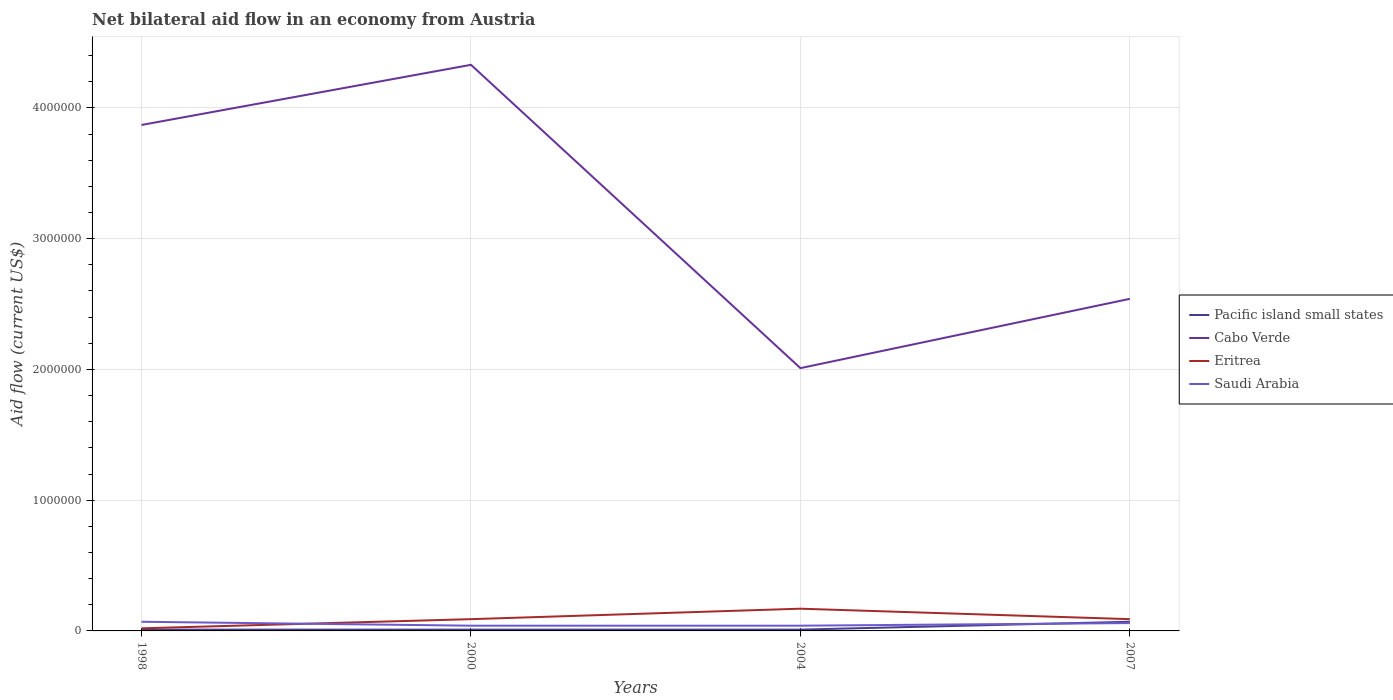Across all years, what is the maximum net bilateral aid flow in Eritrea?
Your answer should be compact. 2.00e+04. In which year was the net bilateral aid flow in Pacific island small states maximum?
Ensure brevity in your answer.  1998. What is the total net bilateral aid flow in Cabo Verde in the graph?
Your answer should be very brief. 2.32e+06. What is the difference between the highest and the lowest net bilateral aid flow in Eritrea?
Provide a succinct answer. 1. How many lines are there?
Make the answer very short. 4. How many years are there in the graph?
Your response must be concise. 4. What is the difference between two consecutive major ticks on the Y-axis?
Make the answer very short. 1.00e+06. Are the values on the major ticks of Y-axis written in scientific E-notation?
Ensure brevity in your answer.  No. Does the graph contain any zero values?
Make the answer very short. No. How are the legend labels stacked?
Offer a terse response. Vertical. What is the title of the graph?
Provide a succinct answer. Net bilateral aid flow in an economy from Austria. Does "Burundi" appear as one of the legend labels in the graph?
Make the answer very short. No. What is the label or title of the Y-axis?
Offer a terse response. Aid flow (current US$). What is the Aid flow (current US$) of Cabo Verde in 1998?
Provide a succinct answer. 3.87e+06. What is the Aid flow (current US$) in Saudi Arabia in 1998?
Give a very brief answer. 7.00e+04. What is the Aid flow (current US$) in Pacific island small states in 2000?
Provide a succinct answer. 10000. What is the Aid flow (current US$) in Cabo Verde in 2000?
Make the answer very short. 4.33e+06. What is the Aid flow (current US$) of Saudi Arabia in 2000?
Your answer should be very brief. 4.00e+04. What is the Aid flow (current US$) in Pacific island small states in 2004?
Your response must be concise. 10000. What is the Aid flow (current US$) of Cabo Verde in 2004?
Provide a short and direct response. 2.01e+06. What is the Aid flow (current US$) of Saudi Arabia in 2004?
Your answer should be very brief. 4.00e+04. What is the Aid flow (current US$) of Cabo Verde in 2007?
Provide a succinct answer. 2.54e+06. Across all years, what is the maximum Aid flow (current US$) in Pacific island small states?
Give a very brief answer. 7.00e+04. Across all years, what is the maximum Aid flow (current US$) in Cabo Verde?
Your answer should be very brief. 4.33e+06. Across all years, what is the maximum Aid flow (current US$) in Saudi Arabia?
Offer a terse response. 7.00e+04. Across all years, what is the minimum Aid flow (current US$) in Cabo Verde?
Your response must be concise. 2.01e+06. What is the total Aid flow (current US$) of Cabo Verde in the graph?
Provide a short and direct response. 1.28e+07. What is the total Aid flow (current US$) in Eritrea in the graph?
Offer a terse response. 3.70e+05. What is the total Aid flow (current US$) of Saudi Arabia in the graph?
Offer a terse response. 2.10e+05. What is the difference between the Aid flow (current US$) in Cabo Verde in 1998 and that in 2000?
Provide a short and direct response. -4.60e+05. What is the difference between the Aid flow (current US$) in Eritrea in 1998 and that in 2000?
Provide a succinct answer. -7.00e+04. What is the difference between the Aid flow (current US$) of Saudi Arabia in 1998 and that in 2000?
Make the answer very short. 3.00e+04. What is the difference between the Aid flow (current US$) of Cabo Verde in 1998 and that in 2004?
Keep it short and to the point. 1.86e+06. What is the difference between the Aid flow (current US$) in Saudi Arabia in 1998 and that in 2004?
Offer a terse response. 3.00e+04. What is the difference between the Aid flow (current US$) in Pacific island small states in 1998 and that in 2007?
Provide a short and direct response. -6.00e+04. What is the difference between the Aid flow (current US$) in Cabo Verde in 1998 and that in 2007?
Provide a short and direct response. 1.33e+06. What is the difference between the Aid flow (current US$) of Cabo Verde in 2000 and that in 2004?
Provide a succinct answer. 2.32e+06. What is the difference between the Aid flow (current US$) in Eritrea in 2000 and that in 2004?
Offer a terse response. -8.00e+04. What is the difference between the Aid flow (current US$) in Cabo Verde in 2000 and that in 2007?
Provide a succinct answer. 1.79e+06. What is the difference between the Aid flow (current US$) in Cabo Verde in 2004 and that in 2007?
Ensure brevity in your answer.  -5.30e+05. What is the difference between the Aid flow (current US$) of Pacific island small states in 1998 and the Aid flow (current US$) of Cabo Verde in 2000?
Your answer should be very brief. -4.32e+06. What is the difference between the Aid flow (current US$) in Cabo Verde in 1998 and the Aid flow (current US$) in Eritrea in 2000?
Offer a very short reply. 3.78e+06. What is the difference between the Aid flow (current US$) of Cabo Verde in 1998 and the Aid flow (current US$) of Saudi Arabia in 2000?
Keep it short and to the point. 3.83e+06. What is the difference between the Aid flow (current US$) in Pacific island small states in 1998 and the Aid flow (current US$) in Eritrea in 2004?
Keep it short and to the point. -1.60e+05. What is the difference between the Aid flow (current US$) in Cabo Verde in 1998 and the Aid flow (current US$) in Eritrea in 2004?
Your answer should be very brief. 3.70e+06. What is the difference between the Aid flow (current US$) of Cabo Verde in 1998 and the Aid flow (current US$) of Saudi Arabia in 2004?
Give a very brief answer. 3.83e+06. What is the difference between the Aid flow (current US$) of Eritrea in 1998 and the Aid flow (current US$) of Saudi Arabia in 2004?
Keep it short and to the point. -2.00e+04. What is the difference between the Aid flow (current US$) of Pacific island small states in 1998 and the Aid flow (current US$) of Cabo Verde in 2007?
Ensure brevity in your answer.  -2.53e+06. What is the difference between the Aid flow (current US$) of Pacific island small states in 1998 and the Aid flow (current US$) of Saudi Arabia in 2007?
Provide a short and direct response. -5.00e+04. What is the difference between the Aid flow (current US$) in Cabo Verde in 1998 and the Aid flow (current US$) in Eritrea in 2007?
Give a very brief answer. 3.78e+06. What is the difference between the Aid flow (current US$) of Cabo Verde in 1998 and the Aid flow (current US$) of Saudi Arabia in 2007?
Your answer should be compact. 3.81e+06. What is the difference between the Aid flow (current US$) in Pacific island small states in 2000 and the Aid flow (current US$) in Cabo Verde in 2004?
Your response must be concise. -2.00e+06. What is the difference between the Aid flow (current US$) of Pacific island small states in 2000 and the Aid flow (current US$) of Eritrea in 2004?
Provide a succinct answer. -1.60e+05. What is the difference between the Aid flow (current US$) of Cabo Verde in 2000 and the Aid flow (current US$) of Eritrea in 2004?
Provide a short and direct response. 4.16e+06. What is the difference between the Aid flow (current US$) in Cabo Verde in 2000 and the Aid flow (current US$) in Saudi Arabia in 2004?
Offer a very short reply. 4.29e+06. What is the difference between the Aid flow (current US$) in Eritrea in 2000 and the Aid flow (current US$) in Saudi Arabia in 2004?
Make the answer very short. 5.00e+04. What is the difference between the Aid flow (current US$) of Pacific island small states in 2000 and the Aid flow (current US$) of Cabo Verde in 2007?
Your response must be concise. -2.53e+06. What is the difference between the Aid flow (current US$) of Pacific island small states in 2000 and the Aid flow (current US$) of Saudi Arabia in 2007?
Your response must be concise. -5.00e+04. What is the difference between the Aid flow (current US$) of Cabo Verde in 2000 and the Aid flow (current US$) of Eritrea in 2007?
Offer a very short reply. 4.24e+06. What is the difference between the Aid flow (current US$) in Cabo Verde in 2000 and the Aid flow (current US$) in Saudi Arabia in 2007?
Your response must be concise. 4.27e+06. What is the difference between the Aid flow (current US$) in Eritrea in 2000 and the Aid flow (current US$) in Saudi Arabia in 2007?
Your answer should be very brief. 3.00e+04. What is the difference between the Aid flow (current US$) in Pacific island small states in 2004 and the Aid flow (current US$) in Cabo Verde in 2007?
Offer a very short reply. -2.53e+06. What is the difference between the Aid flow (current US$) in Pacific island small states in 2004 and the Aid flow (current US$) in Eritrea in 2007?
Your answer should be compact. -8.00e+04. What is the difference between the Aid flow (current US$) in Cabo Verde in 2004 and the Aid flow (current US$) in Eritrea in 2007?
Keep it short and to the point. 1.92e+06. What is the difference between the Aid flow (current US$) of Cabo Verde in 2004 and the Aid flow (current US$) of Saudi Arabia in 2007?
Provide a succinct answer. 1.95e+06. What is the average Aid flow (current US$) of Pacific island small states per year?
Your answer should be compact. 2.50e+04. What is the average Aid flow (current US$) of Cabo Verde per year?
Provide a succinct answer. 3.19e+06. What is the average Aid flow (current US$) in Eritrea per year?
Offer a very short reply. 9.25e+04. What is the average Aid flow (current US$) of Saudi Arabia per year?
Your answer should be very brief. 5.25e+04. In the year 1998, what is the difference between the Aid flow (current US$) in Pacific island small states and Aid flow (current US$) in Cabo Verde?
Your response must be concise. -3.86e+06. In the year 1998, what is the difference between the Aid flow (current US$) of Cabo Verde and Aid flow (current US$) of Eritrea?
Provide a succinct answer. 3.85e+06. In the year 1998, what is the difference between the Aid flow (current US$) of Cabo Verde and Aid flow (current US$) of Saudi Arabia?
Keep it short and to the point. 3.80e+06. In the year 2000, what is the difference between the Aid flow (current US$) in Pacific island small states and Aid flow (current US$) in Cabo Verde?
Provide a short and direct response. -4.32e+06. In the year 2000, what is the difference between the Aid flow (current US$) in Cabo Verde and Aid flow (current US$) in Eritrea?
Ensure brevity in your answer.  4.24e+06. In the year 2000, what is the difference between the Aid flow (current US$) in Cabo Verde and Aid flow (current US$) in Saudi Arabia?
Your answer should be compact. 4.29e+06. In the year 2000, what is the difference between the Aid flow (current US$) in Eritrea and Aid flow (current US$) in Saudi Arabia?
Offer a terse response. 5.00e+04. In the year 2004, what is the difference between the Aid flow (current US$) in Pacific island small states and Aid flow (current US$) in Cabo Verde?
Your answer should be very brief. -2.00e+06. In the year 2004, what is the difference between the Aid flow (current US$) in Cabo Verde and Aid flow (current US$) in Eritrea?
Make the answer very short. 1.84e+06. In the year 2004, what is the difference between the Aid flow (current US$) in Cabo Verde and Aid flow (current US$) in Saudi Arabia?
Give a very brief answer. 1.97e+06. In the year 2004, what is the difference between the Aid flow (current US$) in Eritrea and Aid flow (current US$) in Saudi Arabia?
Offer a very short reply. 1.30e+05. In the year 2007, what is the difference between the Aid flow (current US$) in Pacific island small states and Aid flow (current US$) in Cabo Verde?
Your answer should be compact. -2.47e+06. In the year 2007, what is the difference between the Aid flow (current US$) of Pacific island small states and Aid flow (current US$) of Eritrea?
Your answer should be compact. -2.00e+04. In the year 2007, what is the difference between the Aid flow (current US$) of Pacific island small states and Aid flow (current US$) of Saudi Arabia?
Your answer should be very brief. 10000. In the year 2007, what is the difference between the Aid flow (current US$) in Cabo Verde and Aid flow (current US$) in Eritrea?
Provide a succinct answer. 2.45e+06. In the year 2007, what is the difference between the Aid flow (current US$) in Cabo Verde and Aid flow (current US$) in Saudi Arabia?
Your response must be concise. 2.48e+06. What is the ratio of the Aid flow (current US$) in Pacific island small states in 1998 to that in 2000?
Your answer should be very brief. 1. What is the ratio of the Aid flow (current US$) of Cabo Verde in 1998 to that in 2000?
Ensure brevity in your answer.  0.89. What is the ratio of the Aid flow (current US$) of Eritrea in 1998 to that in 2000?
Keep it short and to the point. 0.22. What is the ratio of the Aid flow (current US$) in Pacific island small states in 1998 to that in 2004?
Give a very brief answer. 1. What is the ratio of the Aid flow (current US$) in Cabo Verde in 1998 to that in 2004?
Give a very brief answer. 1.93. What is the ratio of the Aid flow (current US$) of Eritrea in 1998 to that in 2004?
Your answer should be very brief. 0.12. What is the ratio of the Aid flow (current US$) of Pacific island small states in 1998 to that in 2007?
Offer a terse response. 0.14. What is the ratio of the Aid flow (current US$) in Cabo Verde in 1998 to that in 2007?
Make the answer very short. 1.52. What is the ratio of the Aid flow (current US$) of Eritrea in 1998 to that in 2007?
Your response must be concise. 0.22. What is the ratio of the Aid flow (current US$) in Pacific island small states in 2000 to that in 2004?
Give a very brief answer. 1. What is the ratio of the Aid flow (current US$) in Cabo Verde in 2000 to that in 2004?
Provide a short and direct response. 2.15. What is the ratio of the Aid flow (current US$) in Eritrea in 2000 to that in 2004?
Offer a terse response. 0.53. What is the ratio of the Aid flow (current US$) of Pacific island small states in 2000 to that in 2007?
Give a very brief answer. 0.14. What is the ratio of the Aid flow (current US$) of Cabo Verde in 2000 to that in 2007?
Ensure brevity in your answer.  1.7. What is the ratio of the Aid flow (current US$) of Saudi Arabia in 2000 to that in 2007?
Keep it short and to the point. 0.67. What is the ratio of the Aid flow (current US$) in Pacific island small states in 2004 to that in 2007?
Your answer should be very brief. 0.14. What is the ratio of the Aid flow (current US$) in Cabo Verde in 2004 to that in 2007?
Keep it short and to the point. 0.79. What is the ratio of the Aid flow (current US$) in Eritrea in 2004 to that in 2007?
Your response must be concise. 1.89. What is the ratio of the Aid flow (current US$) in Saudi Arabia in 2004 to that in 2007?
Provide a short and direct response. 0.67. What is the difference between the highest and the second highest Aid flow (current US$) in Cabo Verde?
Offer a very short reply. 4.60e+05. What is the difference between the highest and the second highest Aid flow (current US$) of Eritrea?
Give a very brief answer. 8.00e+04. What is the difference between the highest and the lowest Aid flow (current US$) of Pacific island small states?
Give a very brief answer. 6.00e+04. What is the difference between the highest and the lowest Aid flow (current US$) in Cabo Verde?
Ensure brevity in your answer.  2.32e+06. 